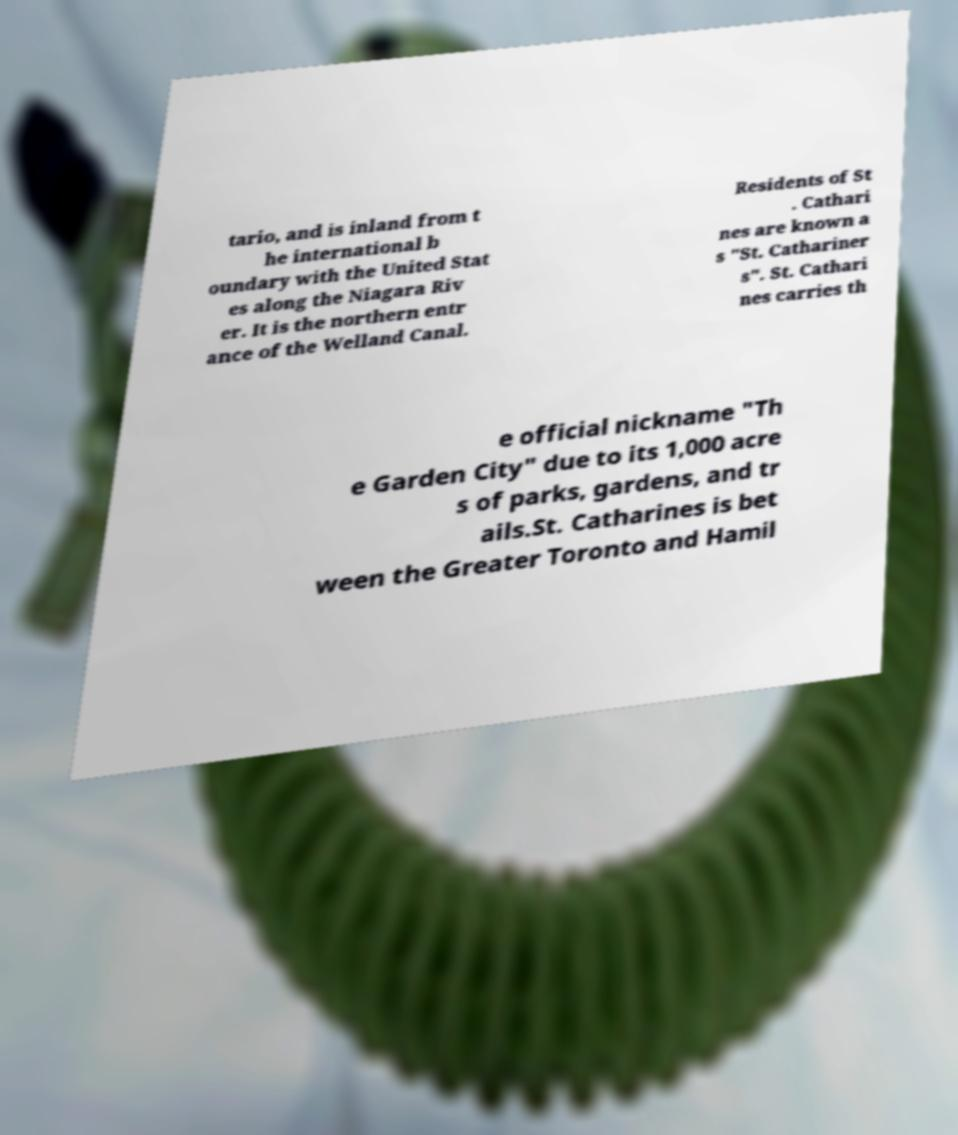For documentation purposes, I need the text within this image transcribed. Could you provide that? tario, and is inland from t he international b oundary with the United Stat es along the Niagara Riv er. It is the northern entr ance of the Welland Canal. Residents of St . Cathari nes are known a s "St. Cathariner s". St. Cathari nes carries th e official nickname "Th e Garden City" due to its 1,000 acre s of parks, gardens, and tr ails.St. Catharines is bet ween the Greater Toronto and Hamil 